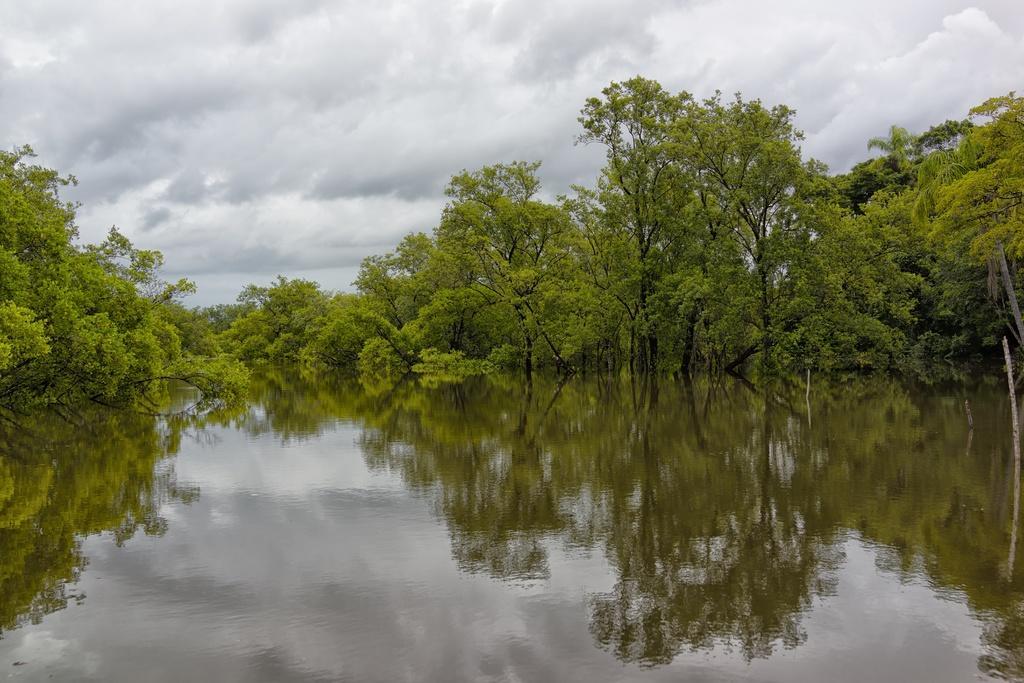Could you give a brief overview of what you see in this image? In this image I can see the water and few trees around the water. In the background I can see the sky. 